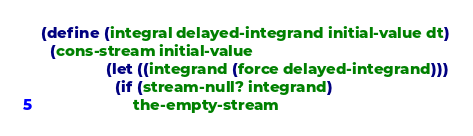<code> <loc_0><loc_0><loc_500><loc_500><_Scheme_>(define (integral delayed-integrand initial-value dt)
  (cons-stream initial-value
               (let ((integrand (force delayed-integrand)))
                 (if (stream-null? integrand)
                     the-empty-stream</code> 